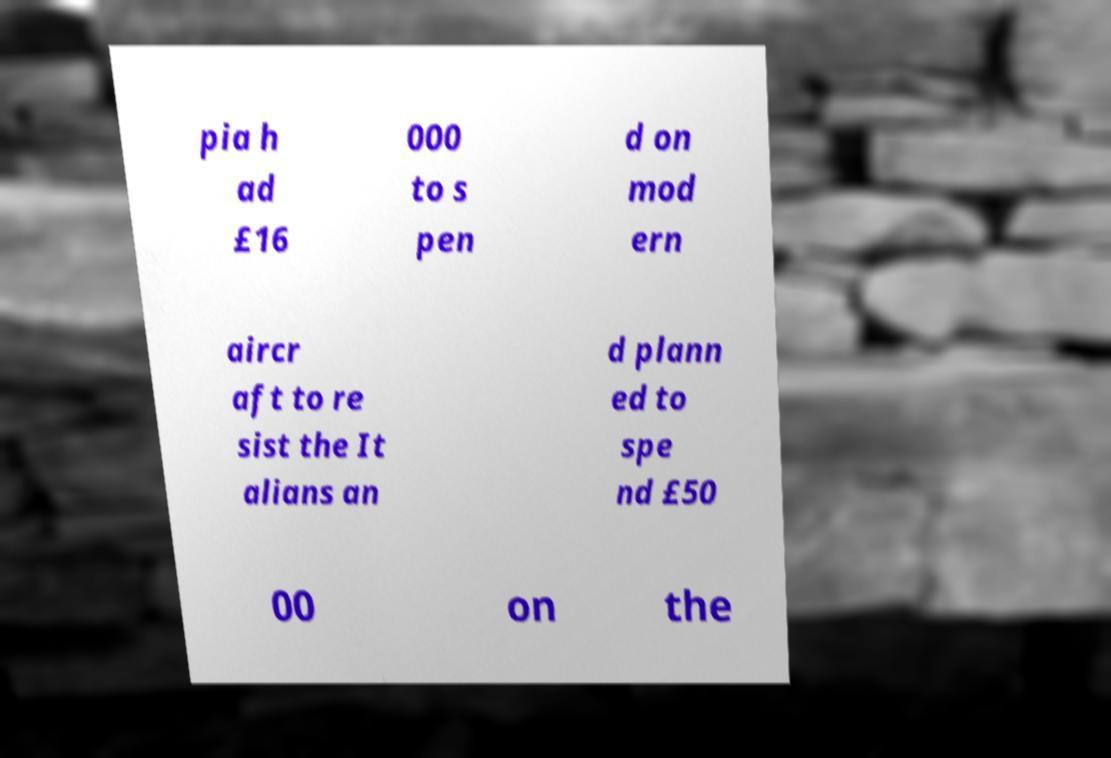Could you extract and type out the text from this image? pia h ad £16 000 to s pen d on mod ern aircr aft to re sist the It alians an d plann ed to spe nd £50 00 on the 